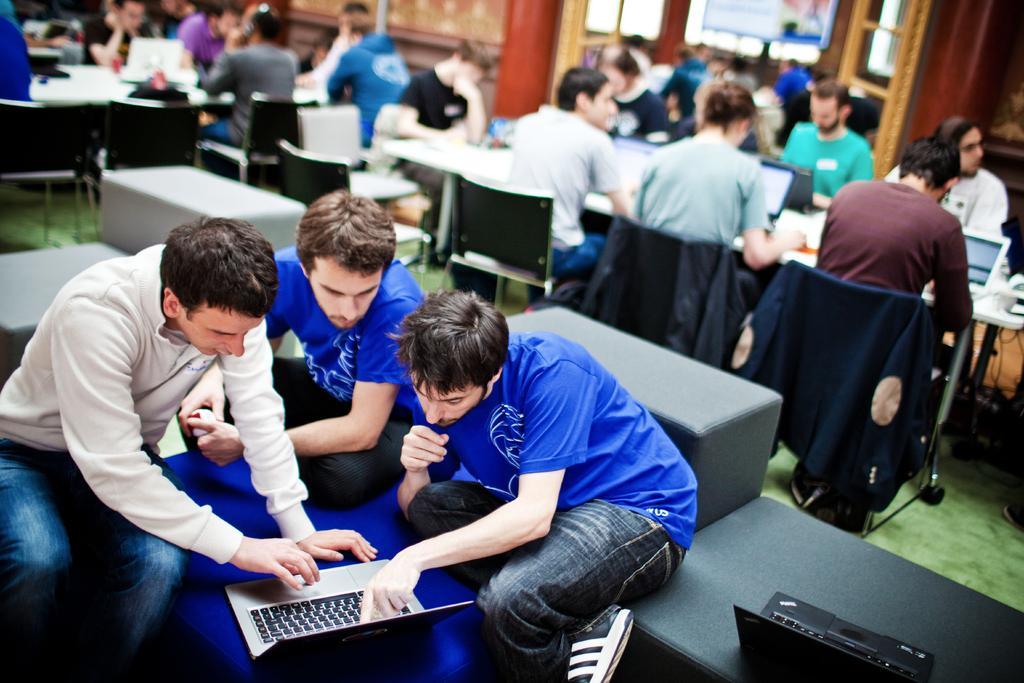In one or two sentences, can you explain what this image depicts? In this picture we can see some people sitting on chairs, in front of tables, we can see laptops on these tables, we can see three persons sitting and looking at a laptop in the front, in the background there is a wall, there is a cloth here. 